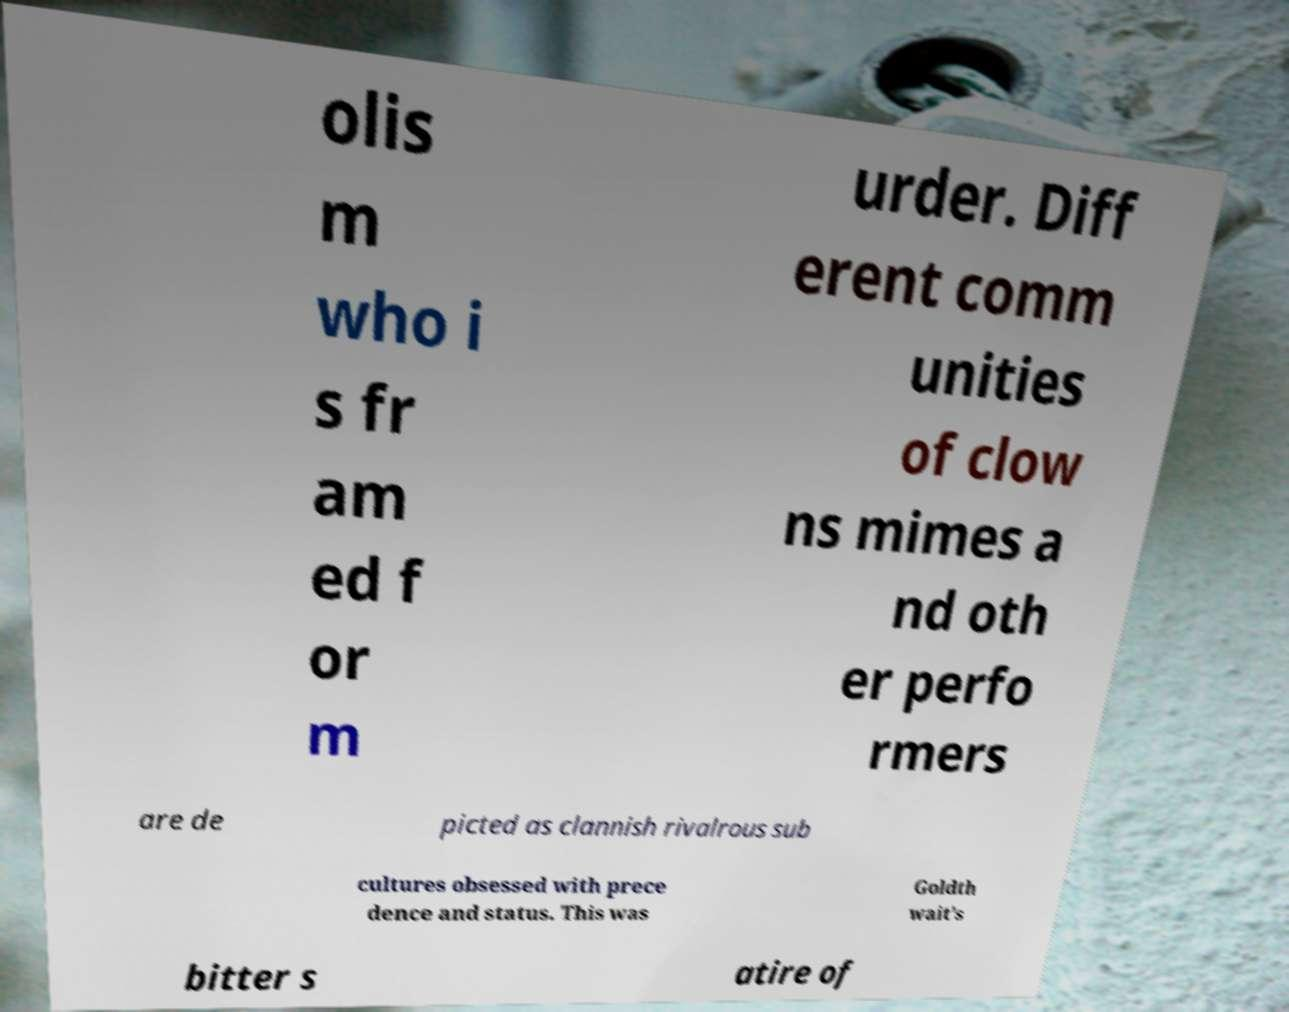For documentation purposes, I need the text within this image transcribed. Could you provide that? olis m who i s fr am ed f or m urder. Diff erent comm unities of clow ns mimes a nd oth er perfo rmers are de picted as clannish rivalrous sub cultures obsessed with prece dence and status. This was Goldth wait's bitter s atire of 